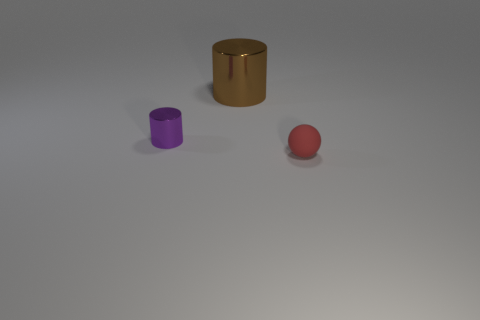Add 1 red matte spheres. How many objects exist? 4 Subtract all spheres. How many objects are left? 2 Add 3 small cyan rubber cylinders. How many small cyan rubber cylinders exist? 3 Subtract 0 purple balls. How many objects are left? 3 Subtract all tiny purple cylinders. Subtract all tiny red rubber balls. How many objects are left? 1 Add 1 small red objects. How many small red objects are left? 2 